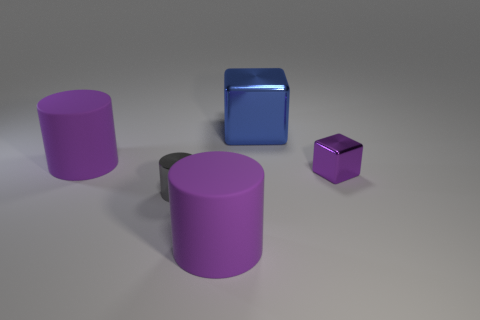What could be the potential use for these objects in a real-world setting? These objects might serve various purposes depending on their actual size and material. For instance, if they were large enough, the cylinders could be used as storage containers or pedestals, while the cubes might function as decorative elements or modular storage units. 